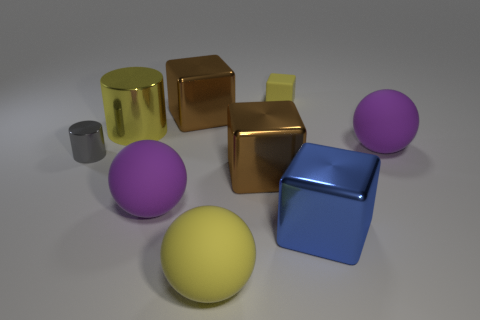Is the small gray shiny object the same shape as the large yellow matte thing?
Ensure brevity in your answer.  No. What number of things are purple objects or large yellow objects that are in front of the large shiny cylinder?
Your answer should be very brief. 3. What number of gray objects are there?
Your response must be concise. 1. Are there any yellow shiny things of the same size as the yellow ball?
Your answer should be compact. Yes. Are there fewer big shiny cylinders that are to the left of the tiny metal thing than yellow blocks?
Your response must be concise. Yes. Is the size of the yellow metal object the same as the rubber block?
Offer a very short reply. No. There is a block that is the same material as the yellow ball; what size is it?
Your response must be concise. Small. How many cylinders are the same color as the small rubber block?
Offer a very short reply. 1. Is the number of matte balls behind the yellow shiny object less than the number of purple matte spheres behind the large blue object?
Your response must be concise. Yes. There is a big rubber object that is right of the yellow sphere; is it the same shape as the tiny yellow rubber thing?
Provide a short and direct response. No. 